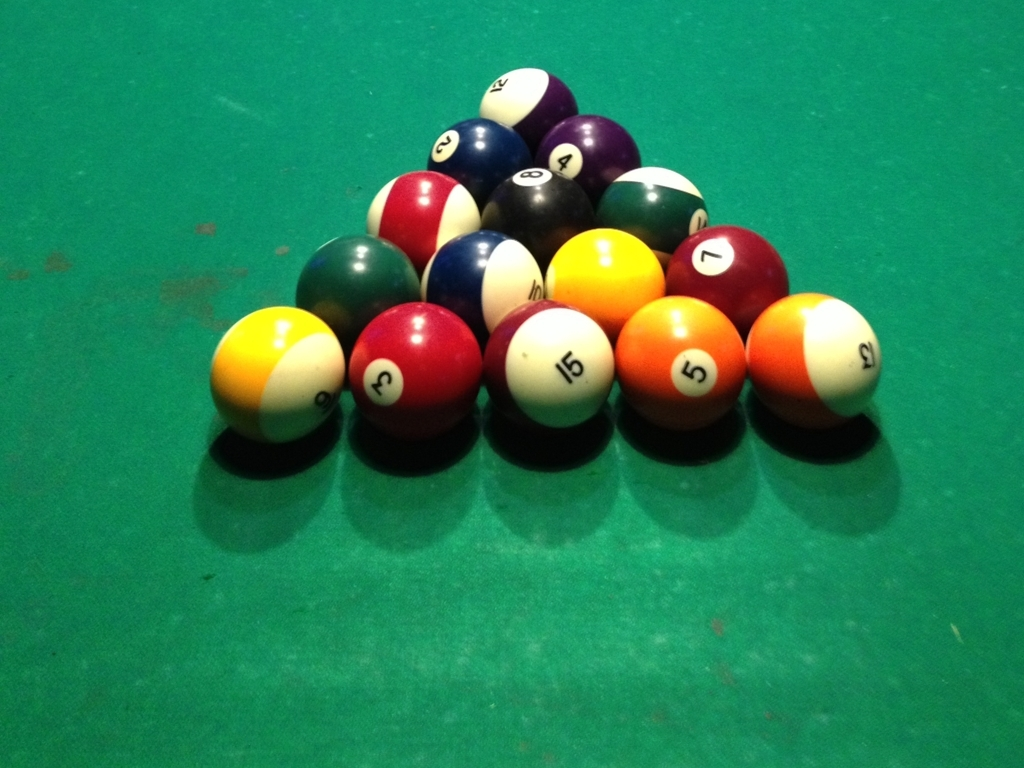Why is the composition of the image described as slightly messy?
A. To complement the decent clarity, but lacks organization.
B. To maintain a clean and neat look.
C. To provide a balanced composition.
Answer with the option's letter from the given choices directly.
 A. 